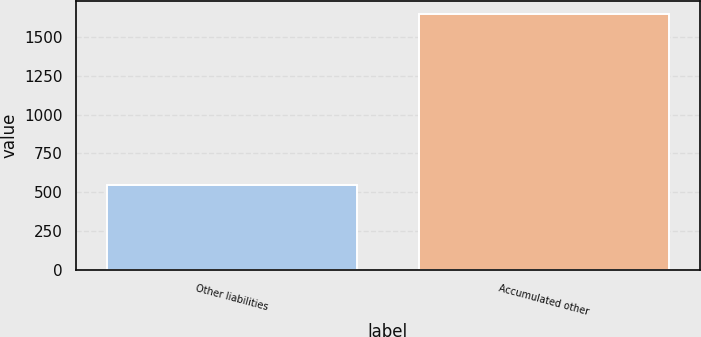<chart> <loc_0><loc_0><loc_500><loc_500><bar_chart><fcel>Other liabilities<fcel>Accumulated other<nl><fcel>544<fcel>1645<nl></chart> 